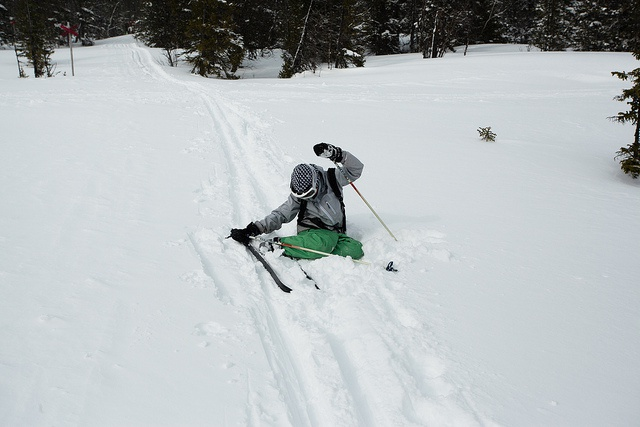Describe the objects in this image and their specific colors. I can see people in black, gray, darkgreen, and lightgray tones and skis in black, lightgray, darkgray, and gray tones in this image. 